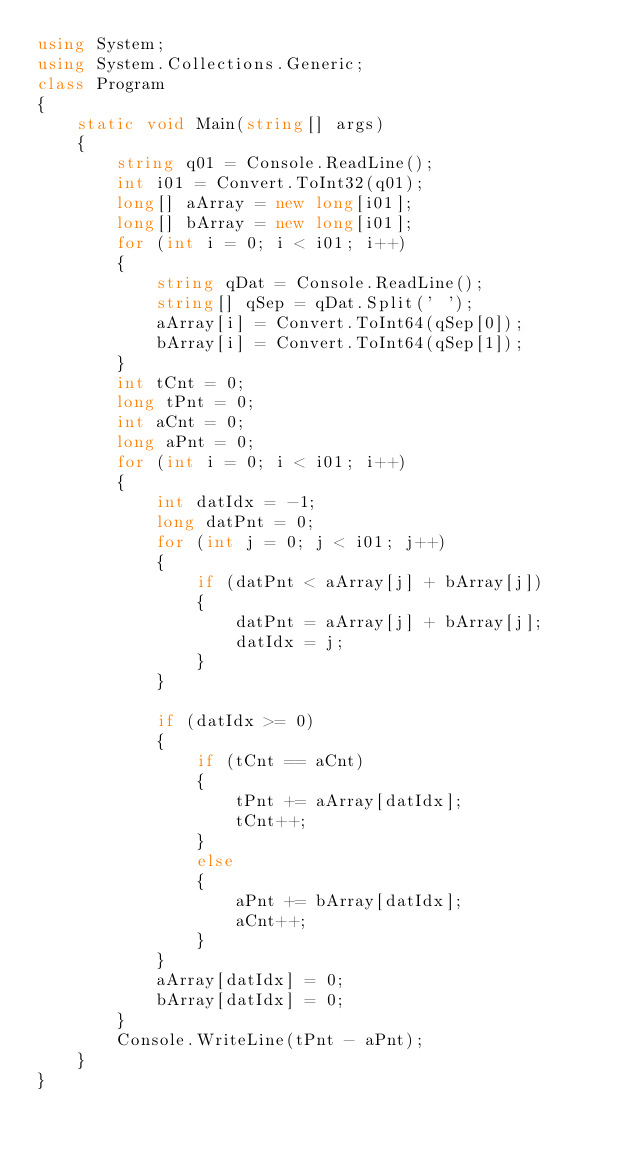Convert code to text. <code><loc_0><loc_0><loc_500><loc_500><_C#_>using System;
using System.Collections.Generic;
class Program
{
    static void Main(string[] args)
    {
        string q01 = Console.ReadLine();
        int i01 = Convert.ToInt32(q01);
        long[] aArray = new long[i01];
        long[] bArray = new long[i01];
        for (int i = 0; i < i01; i++)
        {
            string qDat = Console.ReadLine();
            string[] qSep = qDat.Split(' ');
            aArray[i] = Convert.ToInt64(qSep[0]);
            bArray[i] = Convert.ToInt64(qSep[1]);
        }
        int tCnt = 0;
        long tPnt = 0;
        int aCnt = 0;
        long aPnt = 0;
        for (int i = 0; i < i01; i++)
        {
            int datIdx = -1;
            long datPnt = 0;
            for (int j = 0; j < i01; j++)
            {
                if (datPnt < aArray[j] + bArray[j])
                {
                    datPnt = aArray[j] + bArray[j];
                    datIdx = j;
                }
            }

            if (datIdx >= 0)
            {
                if (tCnt == aCnt)
                {
                    tPnt += aArray[datIdx];
                    tCnt++;
                }
                else
                {
                    aPnt += bArray[datIdx];
                    aCnt++;
                }
            }
            aArray[datIdx] = 0;
            bArray[datIdx] = 0;
        }
        Console.WriteLine(tPnt - aPnt);
    }
}</code> 